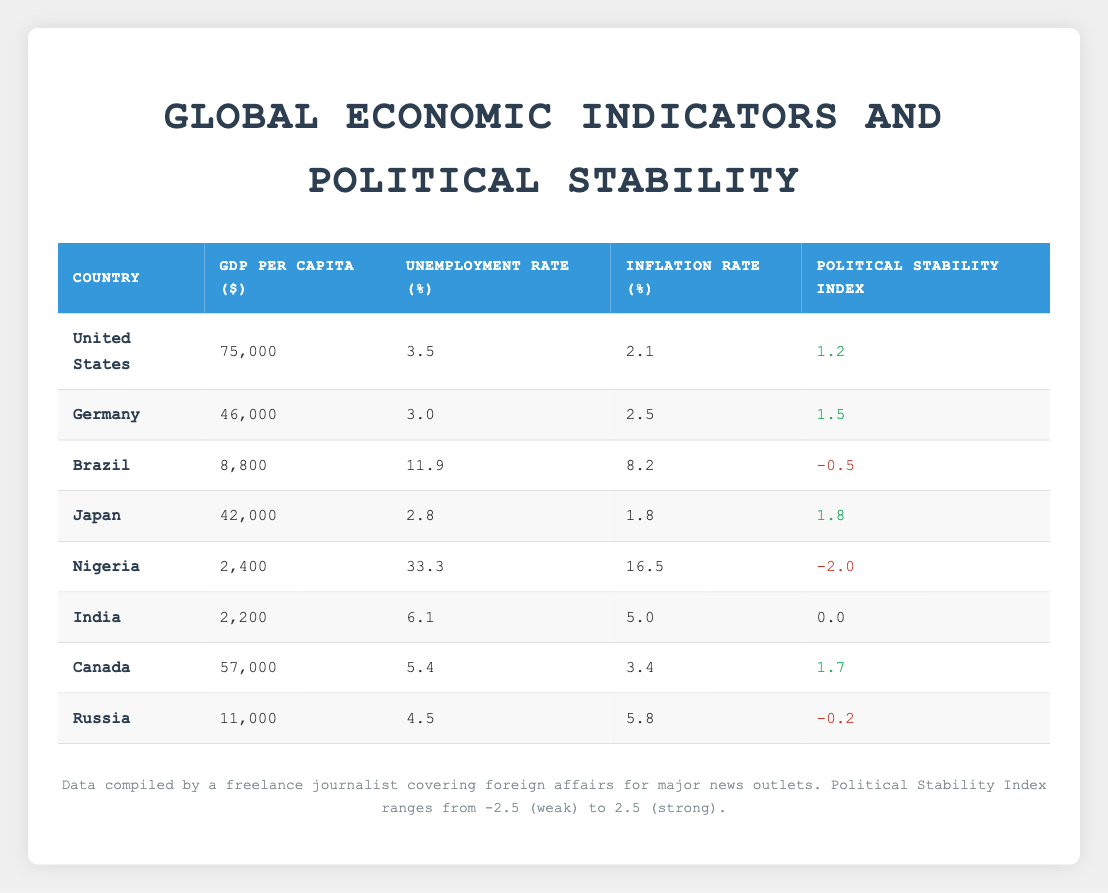What is the GDP per capita of Germany? The table lists GDP per capita next to each country name. For Germany, the value listed is 46,000.
Answer: 46,000 Which country has the highest unemployment rate? To find the highest unemployment rate, we need to compare all rates in the table. Nigeria has an unemployment rate of 33.3%, which is higher than others listed.
Answer: Nigeria What is the average inflation rate across all countries listed? To calculate the average inflation rate, sum all inflation rates: (2.1 + 2.5 + 8.2 + 1.8 + 16.5 + 5.0 + 3.4 + 5.8) = 45.4. There are 8 countries, so the average is 45.4 / 8 = 5.675.
Answer: 5.675 Is India's political stability index above 0? The political stability index for India is 0.0, which is not above zero, so the answer is no.
Answer: No Which country has the lowest GDP per capita and what is its value? Looking at the GDP per capita values, Nigeria has the lowest value at 2,400.
Answer: 2,400 What is the difference in political stability index between the United States and Brazil? The United States has a political stability index of 1.2 and Brazil has -0.5. The difference is 1.2 - (-0.5) = 1.2 + 0.5 = 1.7.
Answer: 1.7 Are the countries with higher GDP per capita generally more politically stable? From inspecting the table, countries like the United States, Germany, and Canada with higher GDP per capita have positive political stability indices. In contrast, countries like Brazil and Nigeria with low GDP per capita have lower stability indices. So we can conclude that higher GDP per capita tends to correlate with better political stability.
Answer: Yes What is the relationship between the inflation rate in Japan and the unemployment rate in Canada? Japan has an inflation rate of 1.8% and Canada has an unemployment rate of 5.4%. There is no direct correlation here, but both rates are relatively low compared to other countries, indicating different aspects of economic health.
Answer: No direct relationship Which country has the best political stability index, and what is it? By checking the political stability index values, Japan has the highest index at 1.8.
Answer: 1.8 